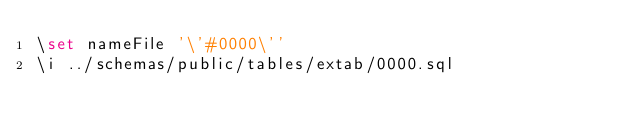Convert code to text. <code><loc_0><loc_0><loc_500><loc_500><_SQL_>\set nameFile '\'#0000\''
\i ../schemas/public/tables/extab/0000.sql</code> 